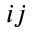Convert formula to latex. <formula><loc_0><loc_0><loc_500><loc_500>i j</formula> 